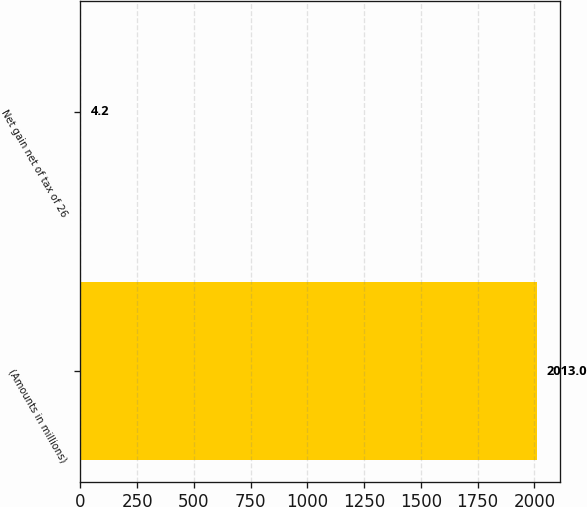Convert chart. <chart><loc_0><loc_0><loc_500><loc_500><bar_chart><fcel>(Amounts in millions)<fcel>Net gain net of tax of 26<nl><fcel>2013<fcel>4.2<nl></chart> 